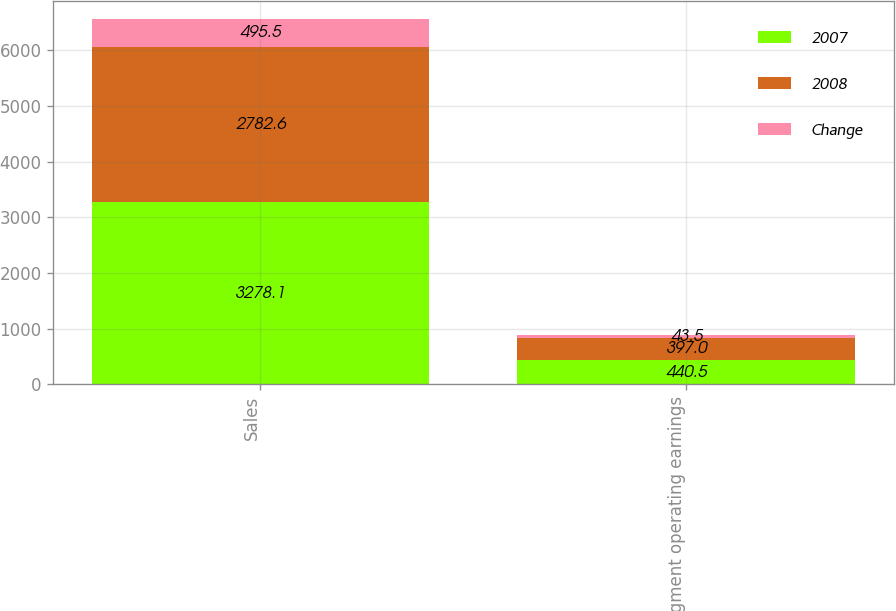Convert chart to OTSL. <chart><loc_0><loc_0><loc_500><loc_500><stacked_bar_chart><ecel><fcel>Sales<fcel>Segment operating earnings<nl><fcel>2007<fcel>3278.1<fcel>440.5<nl><fcel>2008<fcel>2782.6<fcel>397<nl><fcel>Change<fcel>495.5<fcel>43.5<nl></chart> 